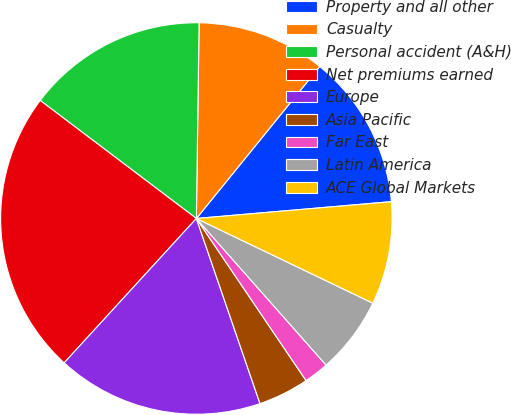<chart> <loc_0><loc_0><loc_500><loc_500><pie_chart><fcel>Property and all other<fcel>Casualty<fcel>Personal accident (A&H)<fcel>Net premiums earned<fcel>Europe<fcel>Asia Pacific<fcel>Far East<fcel>Latin America<fcel>ACE Global Markets<nl><fcel>12.78%<fcel>10.63%<fcel>14.92%<fcel>23.5%<fcel>17.07%<fcel>4.2%<fcel>2.06%<fcel>6.35%<fcel>8.49%<nl></chart> 